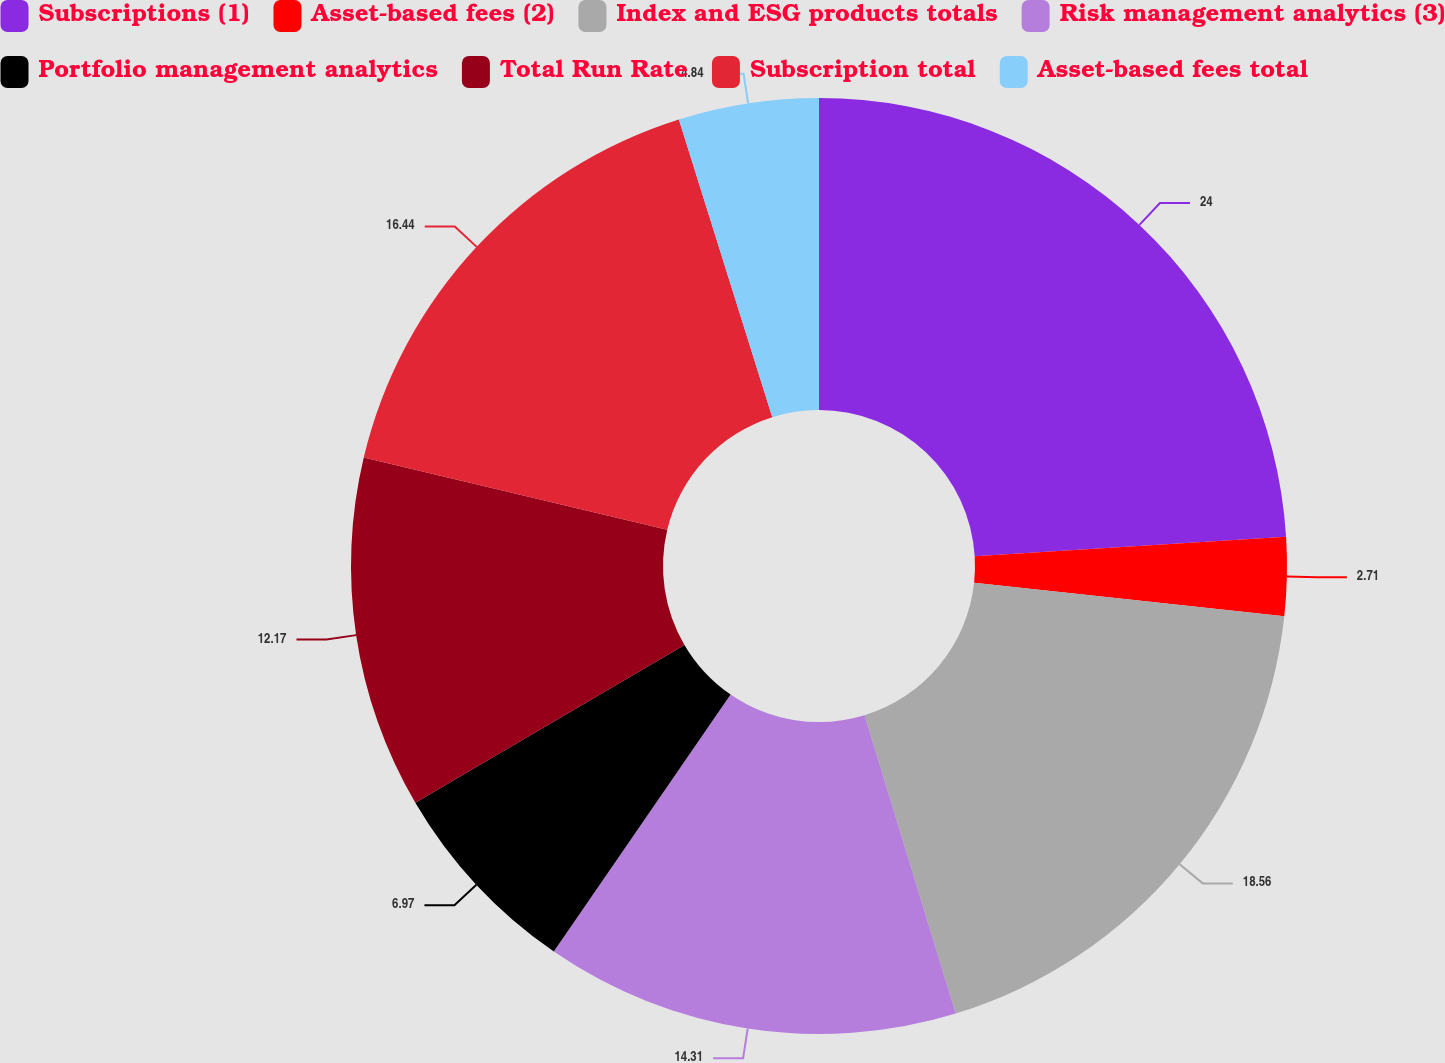<chart> <loc_0><loc_0><loc_500><loc_500><pie_chart><fcel>Subscriptions (1)<fcel>Asset-based fees (2)<fcel>Index and ESG products totals<fcel>Risk management analytics (3)<fcel>Portfolio management analytics<fcel>Total Run Rate<fcel>Subscription total<fcel>Asset-based fees total<nl><fcel>24.01%<fcel>2.71%<fcel>18.57%<fcel>14.31%<fcel>6.97%<fcel>12.17%<fcel>16.44%<fcel>4.84%<nl></chart> 